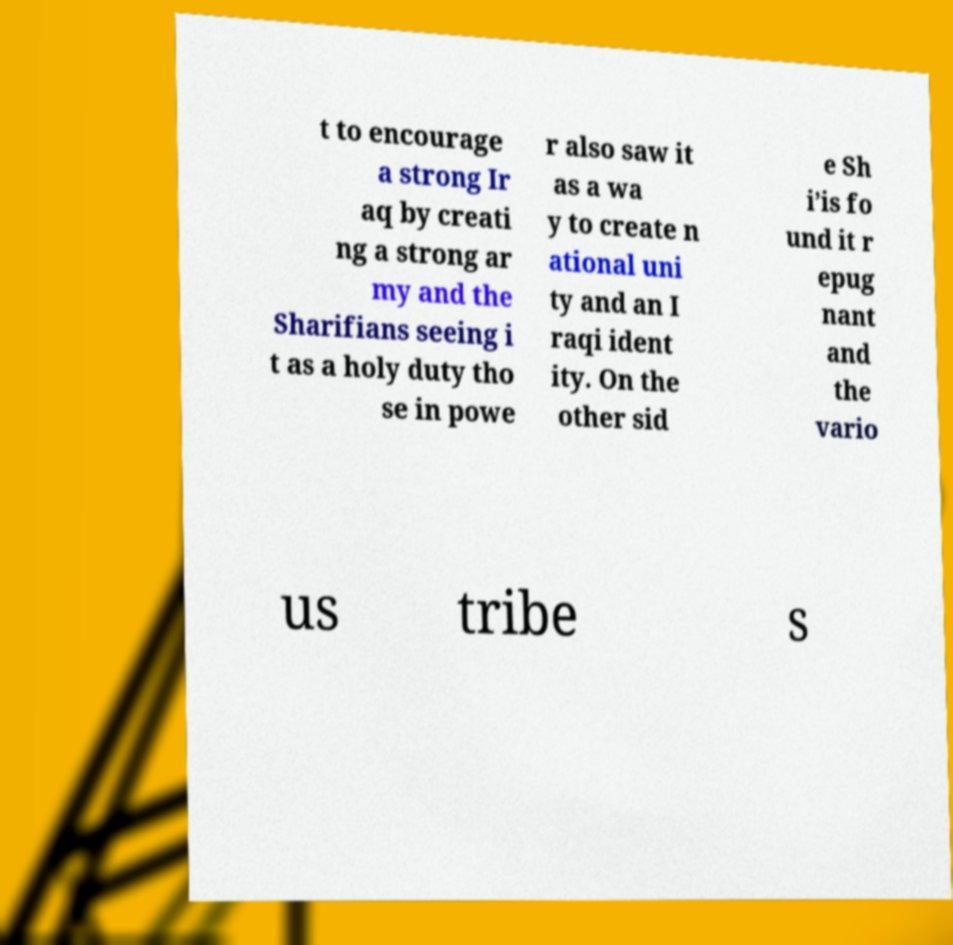Can you read and provide the text displayed in the image?This photo seems to have some interesting text. Can you extract and type it out for me? t to encourage a strong Ir aq by creati ng a strong ar my and the Sharifians seeing i t as a holy duty tho se in powe r also saw it as a wa y to create n ational uni ty and an I raqi ident ity. On the other sid e Sh i’is fo und it r epug nant and the vario us tribe s 